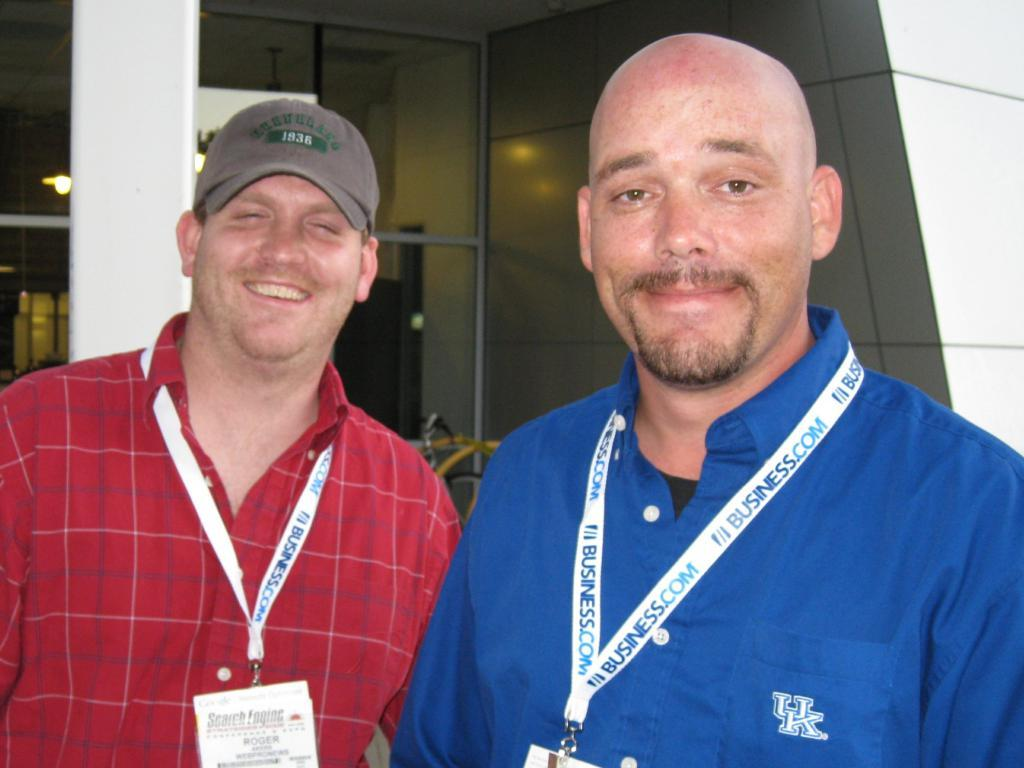<image>
Render a clear and concise summary of the photo. Two men wearing lanyards from the website business.com. 